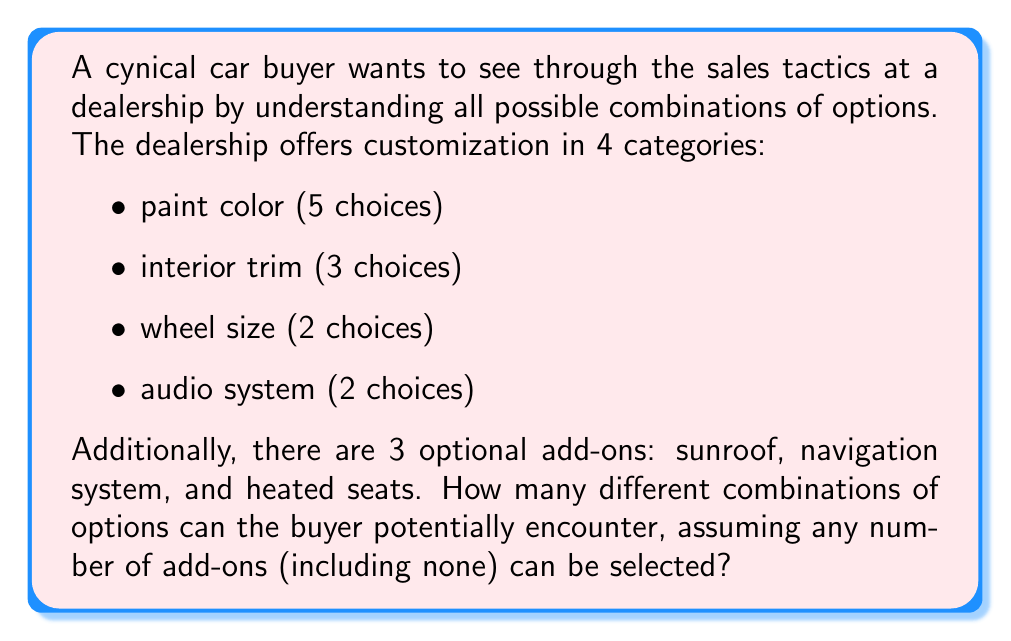Could you help me with this problem? Let's break this down step-by-step:

1) First, let's calculate the number of combinations for the main customization options:
   - Paint color: 5 choices
   - Interior trim: 3 choices
   - Wheel size: 2 choices
   - Audio system: 2 choices

   Using the multiplication principle, we have:
   $$5 \times 3 \times 2 \times 2 = 60$$ combinations for the main options.

2) Now, for the add-ons, we need to consider that each add-on can be either selected or not selected. This creates a binary choice for each add-on. With 3 add-ons, we can use the concept of power sets.

   The number of possible combinations for the add-ons is $2^3 = 8$, because:
   - No add-ons
   - Just sunroof
   - Just navigation system
   - Just heated seats
   - Sunroof and navigation system
   - Sunroof and heated seats
   - Navigation system and heated seats
   - All three add-ons

3) To get the total number of combinations, we multiply the number of combinations for the main options by the number of combinations for the add-ons:

   $$60 \times 8 = 480$$

Thus, there are 480 different combinations of options that the buyer might encounter.
Answer: 480 combinations 